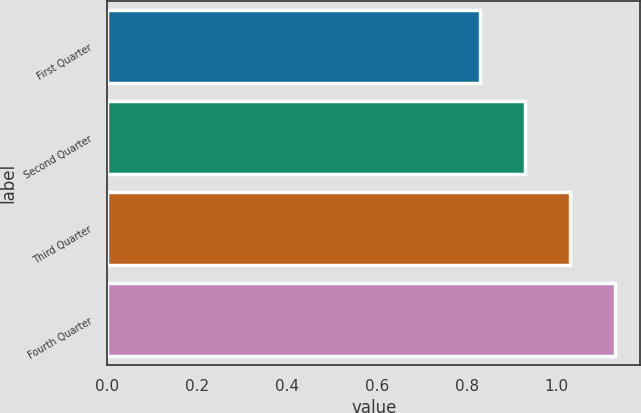<chart> <loc_0><loc_0><loc_500><loc_500><bar_chart><fcel>First Quarter<fcel>Second Quarter<fcel>Third Quarter<fcel>Fourth Quarter<nl><fcel>0.83<fcel>0.93<fcel>1.03<fcel>1.13<nl></chart> 